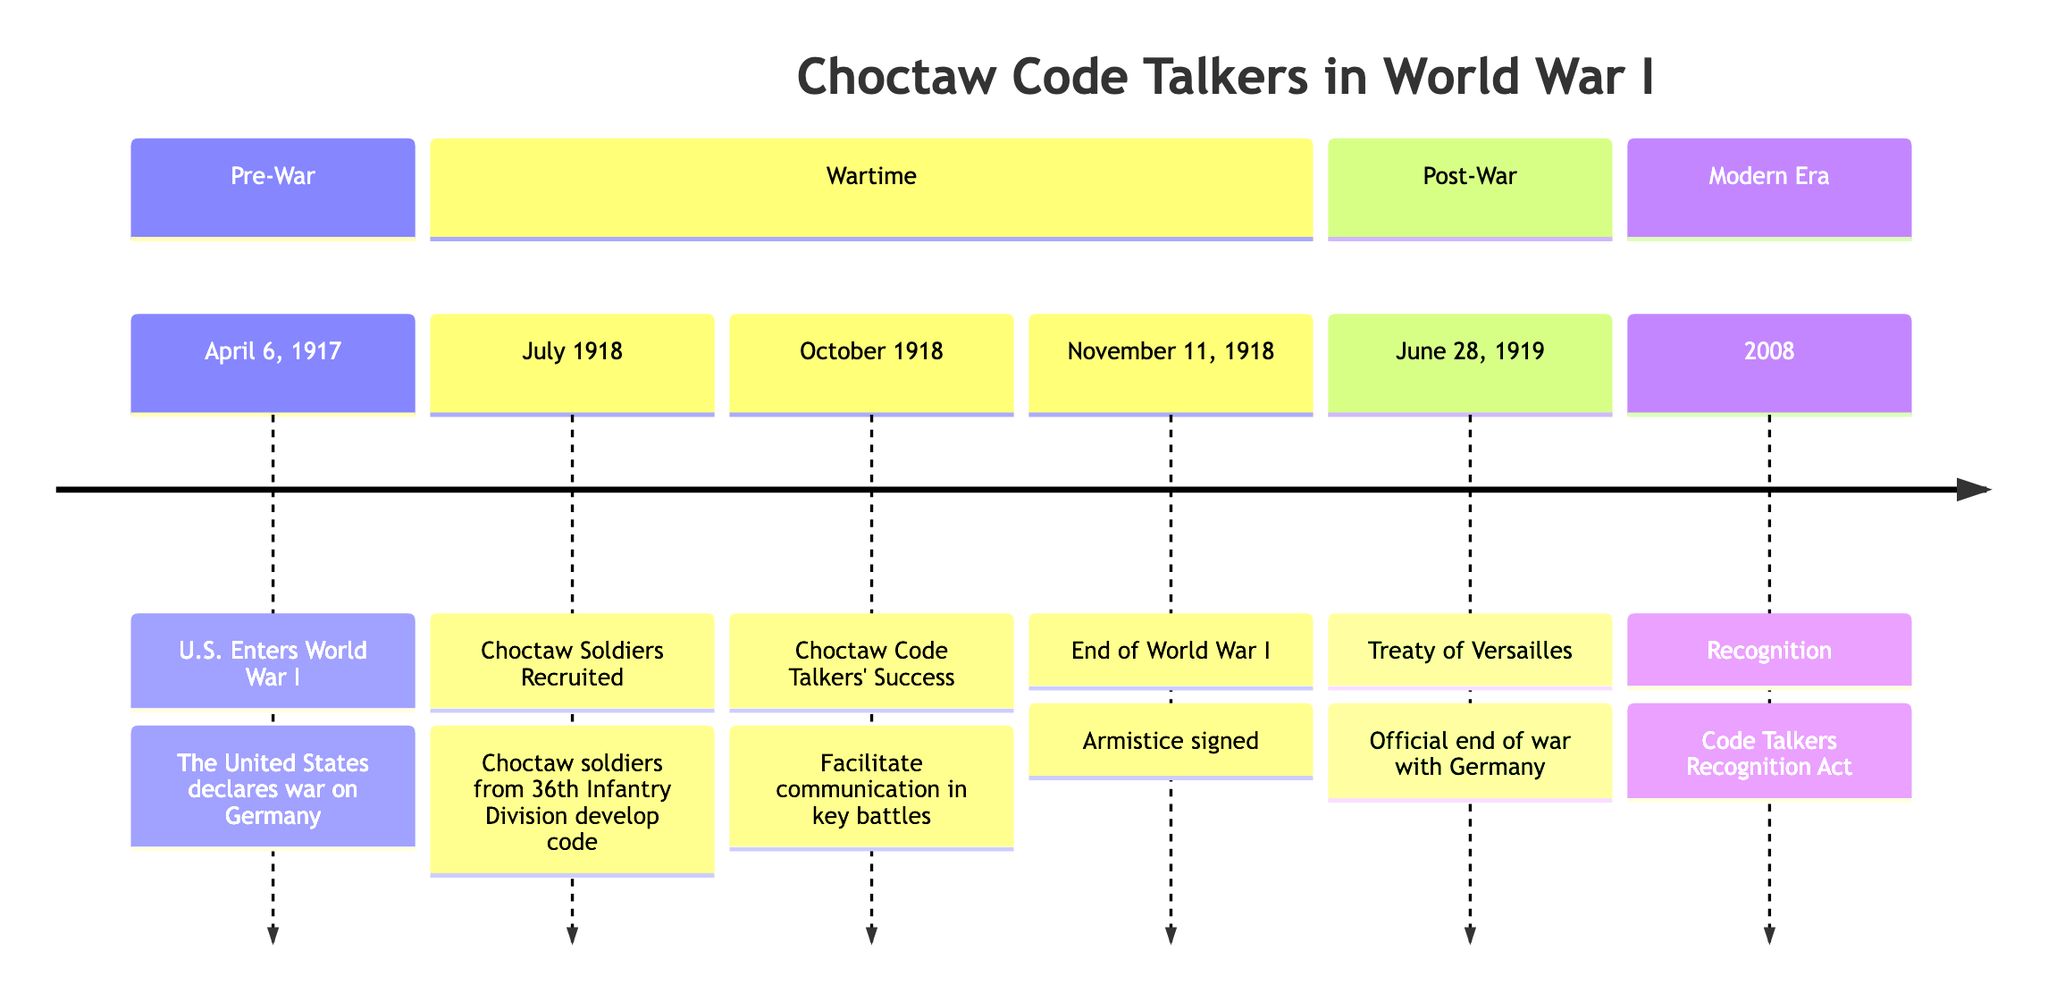What date did the U.S. enter World War I? The diagram clearly displays that the event "U.S. Enters World War I" is linked to the date "April 6, 1917." Thus, this is the specific date marking the entry of the United States into World War I.
Answer: April 6, 1917 What event occurred in July 1918? The timeline makes it clear that in July 1918, Choctaw soldiers are recruited, which details their involvement as military code operators in World War I.
Answer: Choctaw Soldiers Recruited How many key achievements of Choctaw Code Talkers are listed? The timeline shows two significant achievements related to the Choctaw Code Talkers: their recruitment in July 1918 and their success in October 1918, which indicates two key events noted in this timeline.
Answer: 2 What is the last event listed in the timeline? According to the diagram, the last event shown in the timeline is "Recognition," which is documented as occurring in the year 2008. This reflects their formal recognition long after the war.
Answer: Recognition What significant event occurred on November 11, 1918? The timeline specifies that on November 11, 1918, the "End of World War I" took place, indicating that this date marks the signing of the armistice that concluded the hostilities of the war.
Answer: End of World War I What was named on June 28, 1919? The timeline highlights that on June 28, 1919, the "Treaty of Versailles" was signed, serving as the official cessation of the state of war between Germany and the Allied Powers.
Answer: Treaty of Versailles How did Choctaw Code Talkers contribute in October 1918? The diagram indicates that in October 1918, the Choctaw Code Talkers facilitated communication in key battles, which was pivotal as it confused German forces during the conflict.
Answer: Facilitate communication Which section includes the event of the U.S. entering World War I? The event "U.S. Enters World War I," which occurred on April 6, 1917, is categorized under the "Pre-War" section of the timeline diagram.
Answer: Pre-War What act recognized Choctaw Code Talkers' contributions? The diagram shows that the Act which recognized their contributions is titled the "Code Talkers Recognition Act," passed in 2008, highlighting their important role in military history.
Answer: Code Talkers Recognition Act 